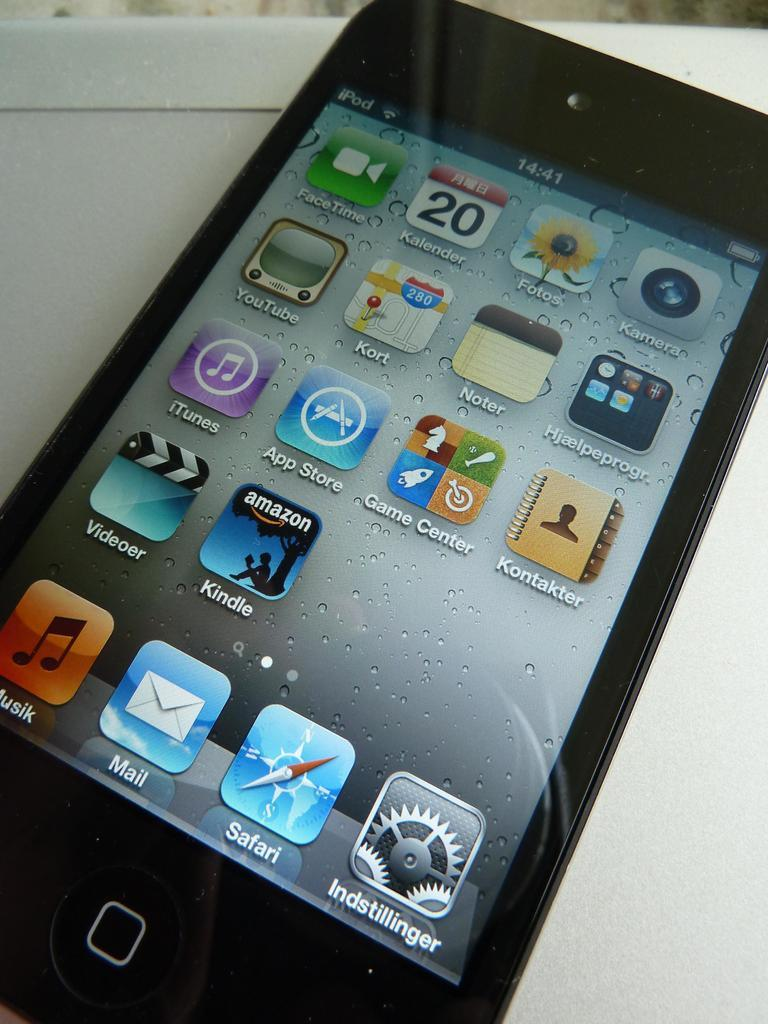<image>
Create a compact narrative representing the image presented. Ipod display screen showing icons for ITunes and the App Store. 